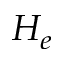Convert formula to latex. <formula><loc_0><loc_0><loc_500><loc_500>H _ { e }</formula> 